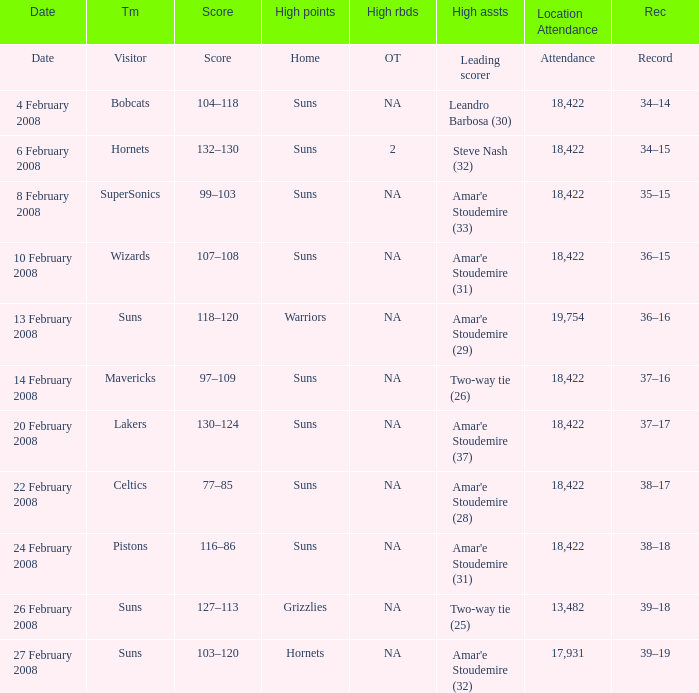How many high assists did the Lakers have? Amar'e Stoudemire (37). 